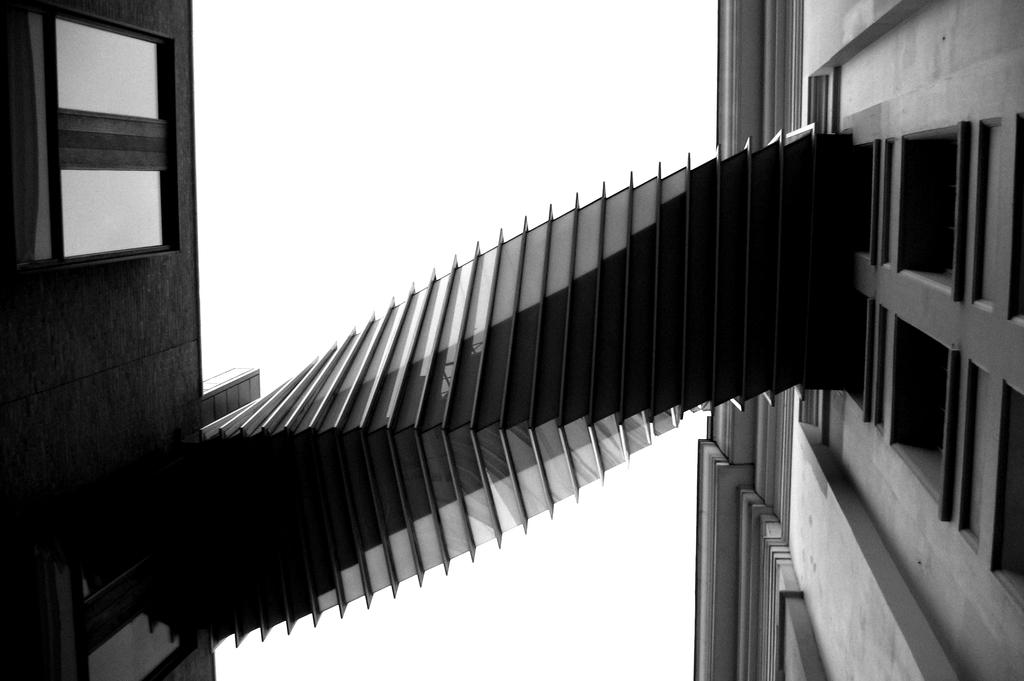What is the color scheme of the image? The image is black and white. How many buildings can be seen in the image? There are two buildings in the image. What is visible at the top of the image? The sky is visible at the top of the image. Where is the quiet rod located in the image? There is no rod or quiet location mentioned in the image; it only features two buildings and the sky. 